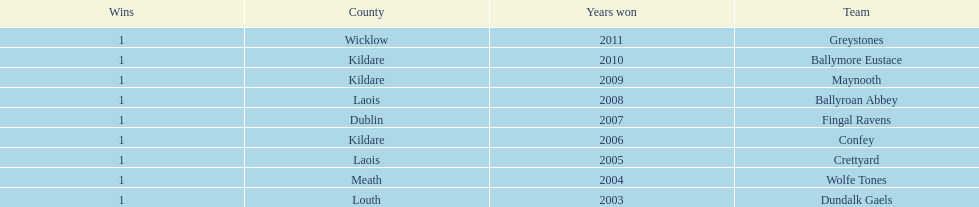How many wins does greystones have? 1. 